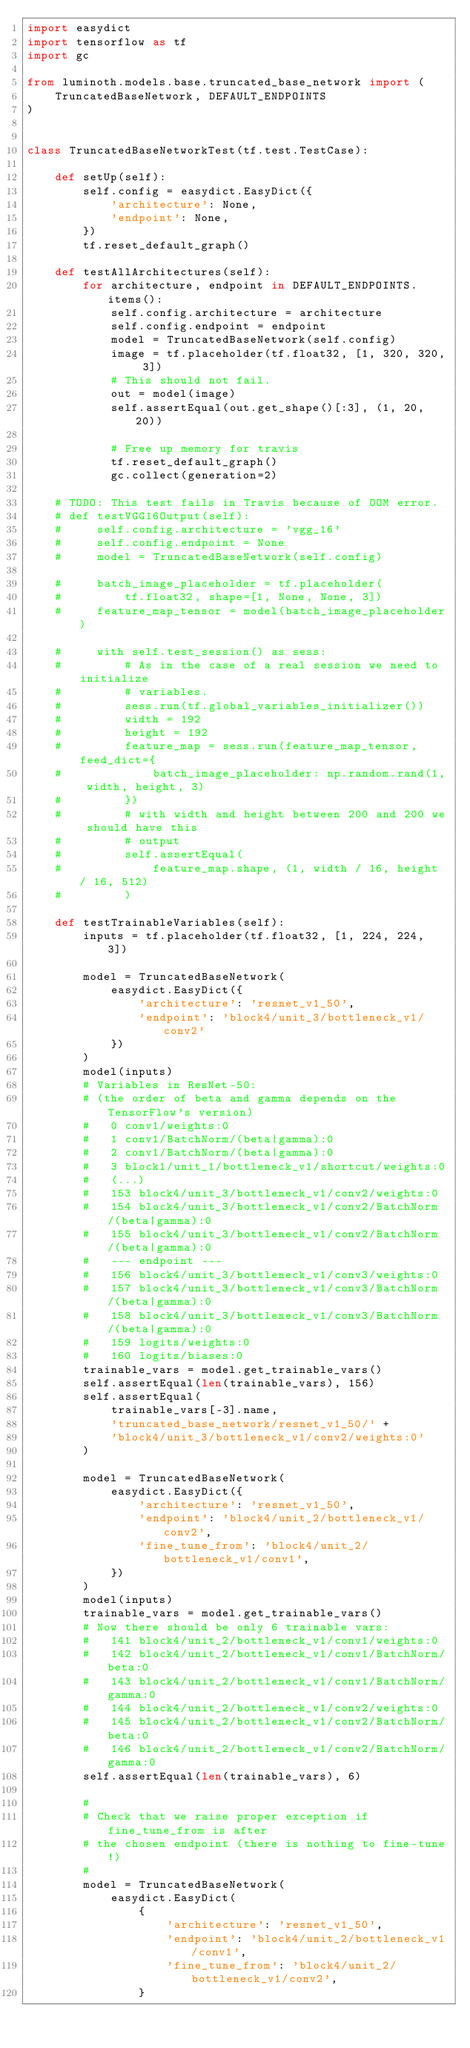Convert code to text. <code><loc_0><loc_0><loc_500><loc_500><_Python_>import easydict
import tensorflow as tf
import gc

from luminoth.models.base.truncated_base_network import (
    TruncatedBaseNetwork, DEFAULT_ENDPOINTS
)


class TruncatedBaseNetworkTest(tf.test.TestCase):

    def setUp(self):
        self.config = easydict.EasyDict({
            'architecture': None,
            'endpoint': None,
        })
        tf.reset_default_graph()

    def testAllArchitectures(self):
        for architecture, endpoint in DEFAULT_ENDPOINTS.items():
            self.config.architecture = architecture
            self.config.endpoint = endpoint
            model = TruncatedBaseNetwork(self.config)
            image = tf.placeholder(tf.float32, [1, 320, 320, 3])
            # This should not fail.
            out = model(image)
            self.assertEqual(out.get_shape()[:3], (1, 20, 20))

            # Free up memory for travis
            tf.reset_default_graph()
            gc.collect(generation=2)

    # TODO: This test fails in Travis because of OOM error.
    # def testVGG16Output(self):
    #     self.config.architecture = 'vgg_16'
    #     self.config.endpoint = None
    #     model = TruncatedBaseNetwork(self.config)

    #     batch_image_placeholder = tf.placeholder(
    #         tf.float32, shape=[1, None, None, 3])
    #     feature_map_tensor = model(batch_image_placeholder)

    #     with self.test_session() as sess:
    #         # As in the case of a real session we need to initialize
    #         # variables.
    #         sess.run(tf.global_variables_initializer())
    #         width = 192
    #         height = 192
    #         feature_map = sess.run(feature_map_tensor, feed_dict={
    #             batch_image_placeholder: np.random.rand(1, width, height, 3)
    #         })
    #         # with width and height between 200 and 200 we should have this
    #         # output
    #         self.assertEqual(
    #             feature_map.shape, (1, width / 16, height / 16, 512)
    #         )

    def testTrainableVariables(self):
        inputs = tf.placeholder(tf.float32, [1, 224, 224, 3])

        model = TruncatedBaseNetwork(
            easydict.EasyDict({
                'architecture': 'resnet_v1_50',
                'endpoint': 'block4/unit_3/bottleneck_v1/conv2'
            })
        )
        model(inputs)
        # Variables in ResNet-50:
        # (the order of beta and gamma depends on the TensorFlow's version)
        #   0 conv1/weights:0
        #   1 conv1/BatchNorm/(beta|gamma):0
        #   2 conv1/BatchNorm/(beta|gamma):0
        #   3 block1/unit_1/bottleneck_v1/shortcut/weights:0
        #   (...)
        #   153 block4/unit_3/bottleneck_v1/conv2/weights:0
        #   154 block4/unit_3/bottleneck_v1/conv2/BatchNorm/(beta|gamma):0
        #   155 block4/unit_3/bottleneck_v1/conv2/BatchNorm/(beta|gamma):0
        #   --- endpoint ---
        #   156 block4/unit_3/bottleneck_v1/conv3/weights:0
        #   157 block4/unit_3/bottleneck_v1/conv3/BatchNorm/(beta|gamma):0
        #   158 block4/unit_3/bottleneck_v1/conv3/BatchNorm/(beta|gamma):0
        #   159 logits/weights:0
        #   160 logits/biases:0
        trainable_vars = model.get_trainable_vars()
        self.assertEqual(len(trainable_vars), 156)
        self.assertEqual(
            trainable_vars[-3].name,
            'truncated_base_network/resnet_v1_50/' +
            'block4/unit_3/bottleneck_v1/conv2/weights:0'
        )

        model = TruncatedBaseNetwork(
            easydict.EasyDict({
                'architecture': 'resnet_v1_50',
                'endpoint': 'block4/unit_2/bottleneck_v1/conv2',
                'fine_tune_from': 'block4/unit_2/bottleneck_v1/conv1',
            })
        )
        model(inputs)
        trainable_vars = model.get_trainable_vars()
        # Now there should be only 6 trainable vars:
        #   141 block4/unit_2/bottleneck_v1/conv1/weights:0
        #   142 block4/unit_2/bottleneck_v1/conv1/BatchNorm/beta:0
        #   143 block4/unit_2/bottleneck_v1/conv1/BatchNorm/gamma:0
        #   144 block4/unit_2/bottleneck_v1/conv2/weights:0
        #   145 block4/unit_2/bottleneck_v1/conv2/BatchNorm/beta:0
        #   146 block4/unit_2/bottleneck_v1/conv2/BatchNorm/gamma:0
        self.assertEqual(len(trainable_vars), 6)

        #
        # Check that we raise proper exception if fine_tune_from is after
        # the chosen endpoint (there is nothing to fine-tune!)
        #
        model = TruncatedBaseNetwork(
            easydict.EasyDict(
                {
                    'architecture': 'resnet_v1_50',
                    'endpoint': 'block4/unit_2/bottleneck_v1/conv1',
                    'fine_tune_from': 'block4/unit_2/bottleneck_v1/conv2',
                }</code> 